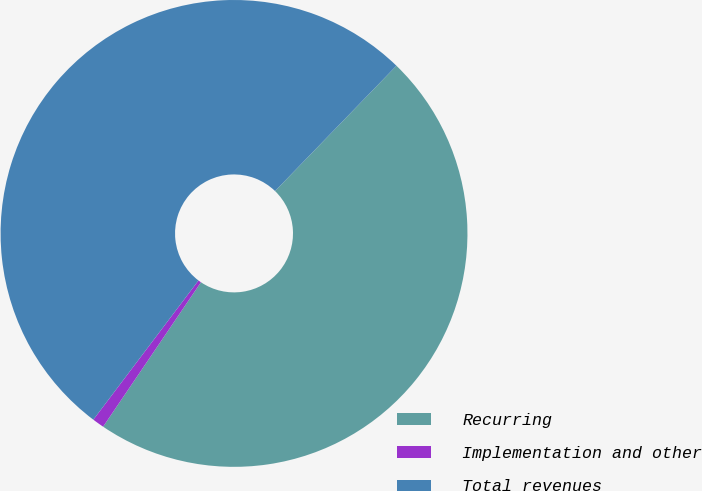Convert chart. <chart><loc_0><loc_0><loc_500><loc_500><pie_chart><fcel>Recurring<fcel>Implementation and other<fcel>Total revenues<nl><fcel>47.23%<fcel>0.82%<fcel>51.95%<nl></chart> 